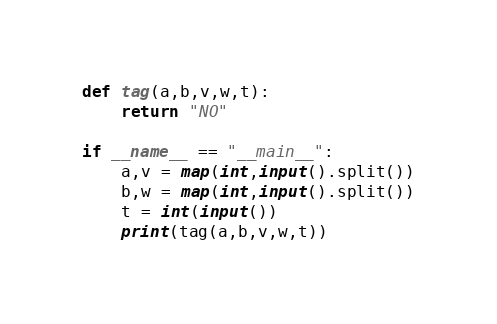Convert code to text. <code><loc_0><loc_0><loc_500><loc_500><_Python_>def tag(a,b,v,w,t):
    return "NO"

if __name__ == "__main__":
    a,v = map(int,input().split())
    b,w = map(int,input().split())
    t = int(input())
    print(tag(a,b,v,w,t))</code> 